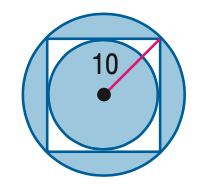Question: Find the area of the shaded region. Assume that all polygons that appear to be regular are regular. Round to the nearest tenth.
Choices:
A. 192.7
B. 271.2
C. 371.2
D. 428.3
Answer with the letter. Answer: B 